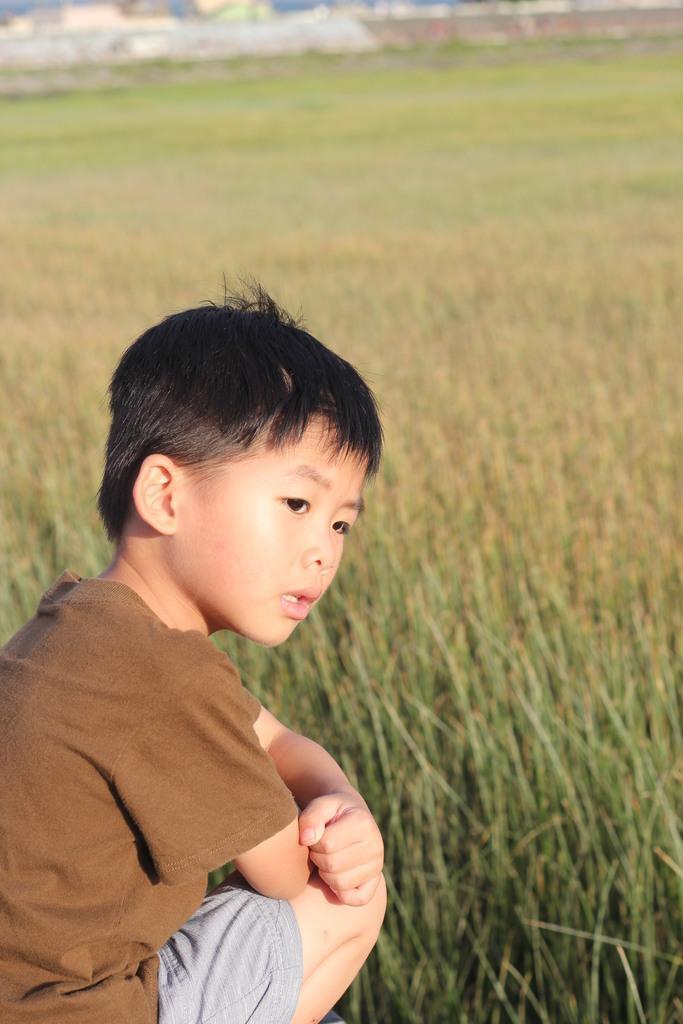Please provide a concise description of this image. In this image, we can see a crop field. There is a kid in the bottom left of the image wearing clothes. 